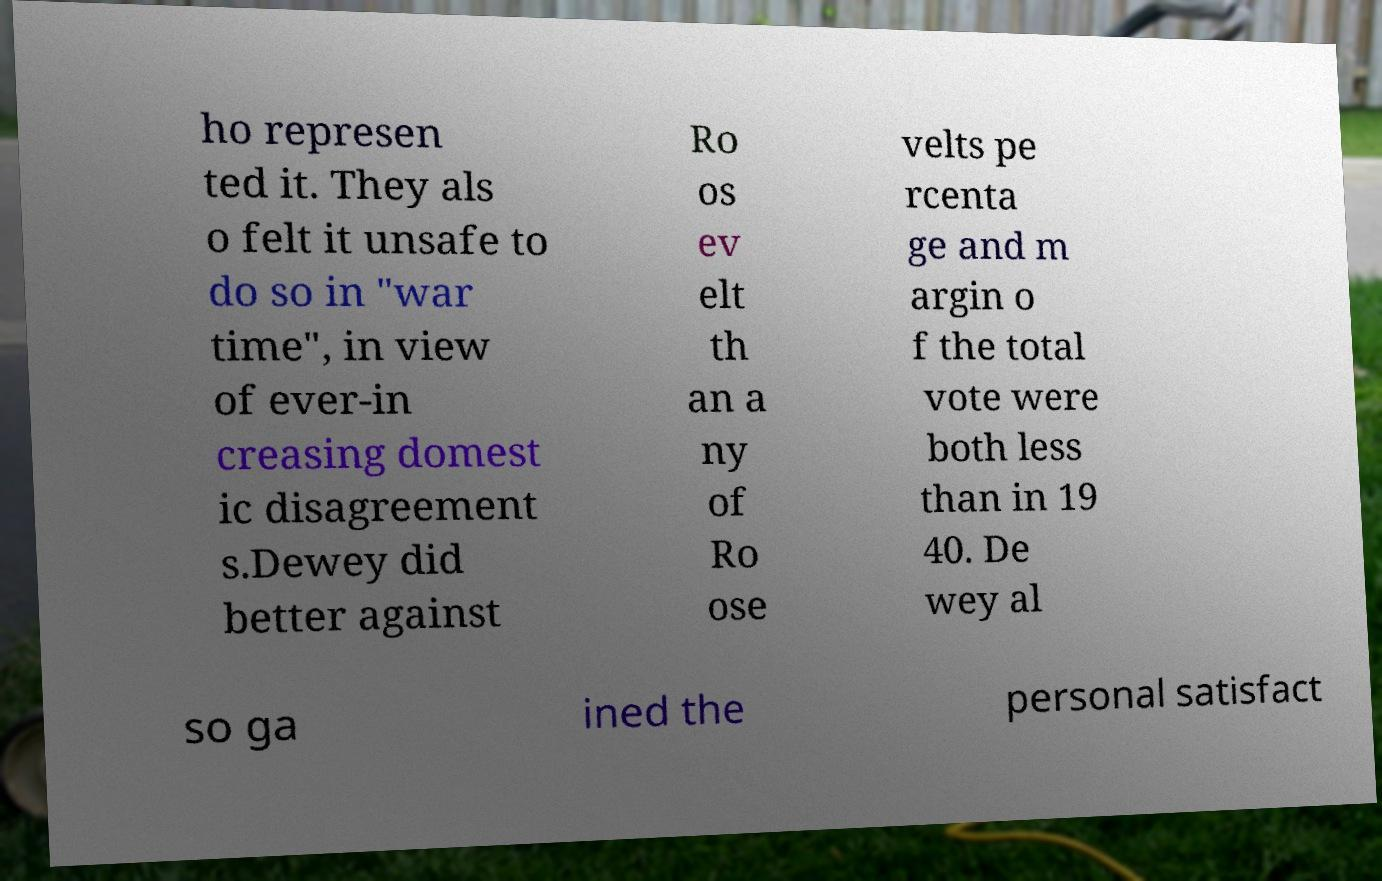I need the written content from this picture converted into text. Can you do that? ho represen ted it. They als o felt it unsafe to do so in "war time", in view of ever-in creasing domest ic disagreement s.Dewey did better against Ro os ev elt th an a ny of Ro ose velts pe rcenta ge and m argin o f the total vote were both less than in 19 40. De wey al so ga ined the personal satisfact 